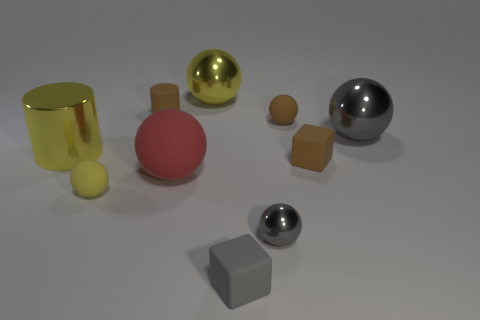Describe the texture and finish of the objects in this composition. The objects display a variety of textures and finishes. The yellow cylinder and the large ball to its right have a reflective, shiny finish, which can be seen in the way they mirror the environment. The red sphere and both gray cubes have a matte finish, diffusing the light and not reflecting their surroundings. The smaller silver and gold balls seem to be somewhere between glossy and matte, with a subdued shine. 